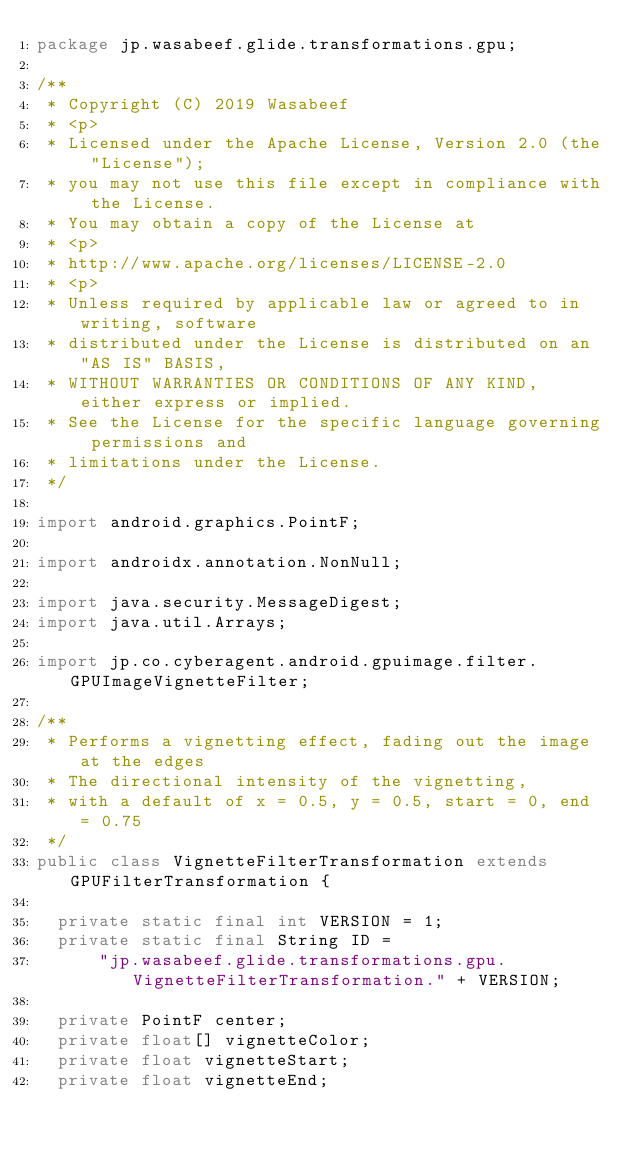Convert code to text. <code><loc_0><loc_0><loc_500><loc_500><_Java_>package jp.wasabeef.glide.transformations.gpu;

/**
 * Copyright (C) 2019 Wasabeef
 * <p>
 * Licensed under the Apache License, Version 2.0 (the "License");
 * you may not use this file except in compliance with the License.
 * You may obtain a copy of the License at
 * <p>
 * http://www.apache.org/licenses/LICENSE-2.0
 * <p>
 * Unless required by applicable law or agreed to in writing, software
 * distributed under the License is distributed on an "AS IS" BASIS,
 * WITHOUT WARRANTIES OR CONDITIONS OF ANY KIND, either express or implied.
 * See the License for the specific language governing permissions and
 * limitations under the License.
 */

import android.graphics.PointF;

import androidx.annotation.NonNull;

import java.security.MessageDigest;
import java.util.Arrays;

import jp.co.cyberagent.android.gpuimage.filter.GPUImageVignetteFilter;

/**
 * Performs a vignetting effect, fading out the image at the edges
 * The directional intensity of the vignetting,
 * with a default of x = 0.5, y = 0.5, start = 0, end = 0.75
 */
public class VignetteFilterTransformation extends GPUFilterTransformation {

  private static final int VERSION = 1;
  private static final String ID =
      "jp.wasabeef.glide.transformations.gpu.VignetteFilterTransformation." + VERSION;

  private PointF center;
  private float[] vignetteColor;
  private float vignetteStart;
  private float vignetteEnd;
</code> 